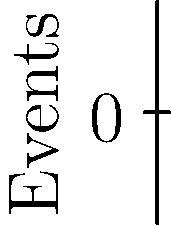In the given timeline visualization of cue sequences for lighting, sound, and stage management, what is the total number of cues that occur within the first 5 minutes of the production? To determine the number of cues within the first 5 minutes, we need to count the events (represented by dots) on each line up to the 5-minute mark:

1. Lighting (blue line):
   - Cues at 2 minutes and 4 minutes
   - Total: 2 cues

2. Sound (red line):
   - Cues at 3 minutes and 5 minutes
   - Total: 2 cues

3. Stage Management (green line):
   - Cues at 1 minute, 3 minutes, and 5 minutes
   - Total: 3 cues

Adding up all the cues:
$2 + 2 + 3 = 7$ cues

Therefore, the total number of cues that occur within the first 5 minutes of the production is 7.
Answer: 7 cues 